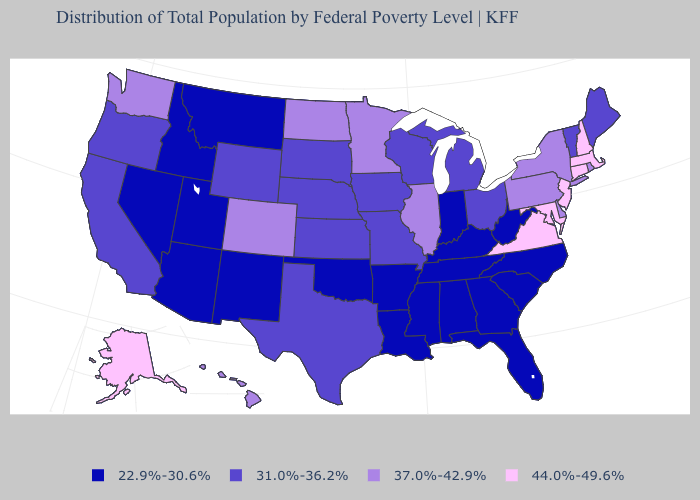Name the states that have a value in the range 31.0%-36.2%?
Give a very brief answer. California, Iowa, Kansas, Maine, Michigan, Missouri, Nebraska, Ohio, Oregon, South Dakota, Texas, Vermont, Wisconsin, Wyoming. Which states hav the highest value in the West?
Write a very short answer. Alaska. Among the states that border Delaware , which have the highest value?
Write a very short answer. Maryland, New Jersey. Does South Carolina have a higher value than Wisconsin?
Write a very short answer. No. What is the value of Minnesota?
Short answer required. 37.0%-42.9%. Which states hav the highest value in the MidWest?
Answer briefly. Illinois, Minnesota, North Dakota. Which states have the lowest value in the Northeast?
Answer briefly. Maine, Vermont. What is the value of Nebraska?
Keep it brief. 31.0%-36.2%. What is the lowest value in states that border Arizona?
Answer briefly. 22.9%-30.6%. Is the legend a continuous bar?
Keep it brief. No. Name the states that have a value in the range 44.0%-49.6%?
Be succinct. Alaska, Connecticut, Maryland, Massachusetts, New Hampshire, New Jersey, Virginia. Among the states that border Indiana , does Illinois have the highest value?
Answer briefly. Yes. Name the states that have a value in the range 22.9%-30.6%?
Concise answer only. Alabama, Arizona, Arkansas, Florida, Georgia, Idaho, Indiana, Kentucky, Louisiana, Mississippi, Montana, Nevada, New Mexico, North Carolina, Oklahoma, South Carolina, Tennessee, Utah, West Virginia. What is the value of North Carolina?
Answer briefly. 22.9%-30.6%. 